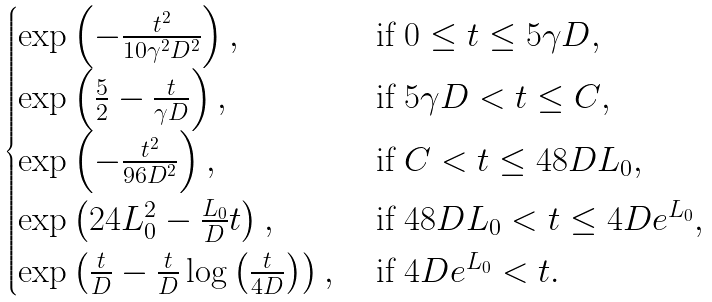Convert formula to latex. <formula><loc_0><loc_0><loc_500><loc_500>\begin{cases} \exp \left ( - \frac { t ^ { 2 } } { 1 0 \gamma ^ { 2 } D ^ { 2 } } \right ) , & \text { if $0\leq t\leq 5\gamma D$} , \\ \exp \left ( \frac { 5 } { 2 } - \frac { t } { \gamma D } \right ) , & \text { if $5\gamma D< t\leq C$} , \\ \exp \left ( - \frac { t ^ { 2 } } { 9 6 D ^ { 2 } } \right ) , & \text { if $C< t\leq 48 DL_{0}$} , \\ \exp \left ( 2 4 L _ { 0 } ^ { 2 } - \frac { L _ { 0 } } { D } t \right ) , & \text { if $48 DL_{0}< t\leq 4De^{L_{0}}$} , \\ \exp \left ( \frac { t } { D } - \frac { t } { D } \log \left ( \frac { t } { 4 D } \right ) \right ) , & \text { if $4De^{L_{0}}< t$} . \end{cases}</formula> 